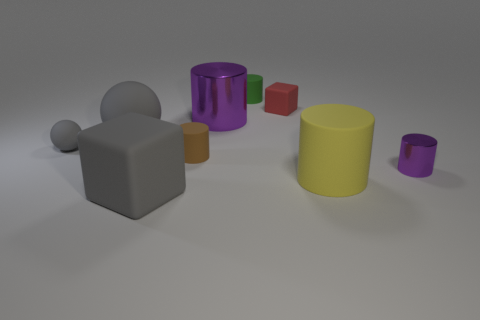Does the yellow cylinder have the same material as the small sphere left of the tiny cube? Yes, the yellow cylinder appears to have a surface texture and matte finish similar to that of the small sphere to the left of the tiny cube, suggesting they have the same material. 